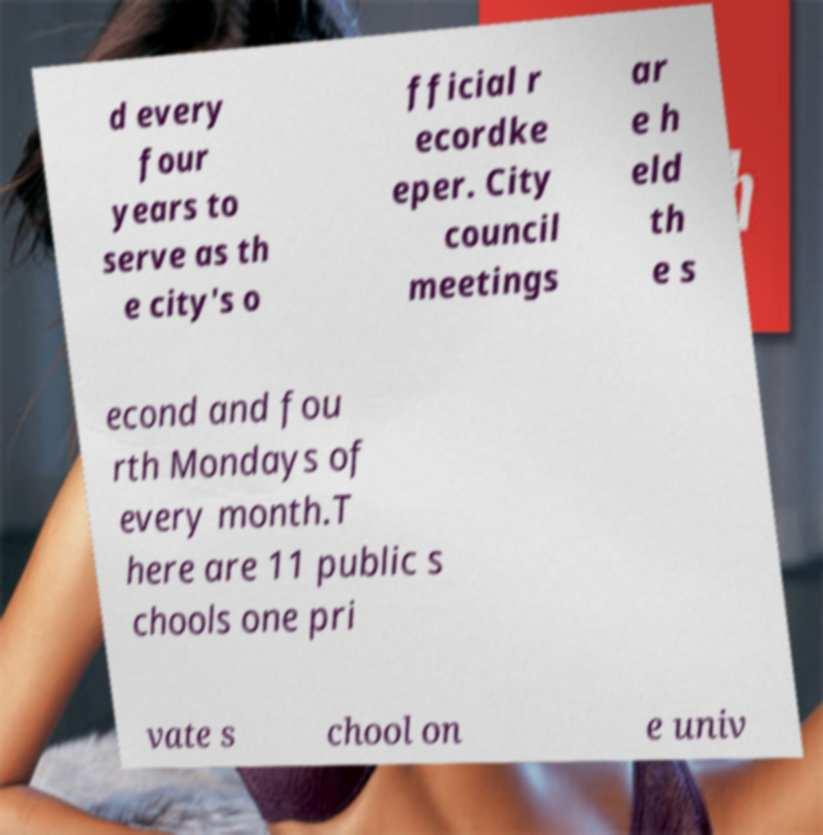I need the written content from this picture converted into text. Can you do that? d every four years to serve as th e city's o fficial r ecordke eper. City council meetings ar e h eld th e s econd and fou rth Mondays of every month.T here are 11 public s chools one pri vate s chool on e univ 